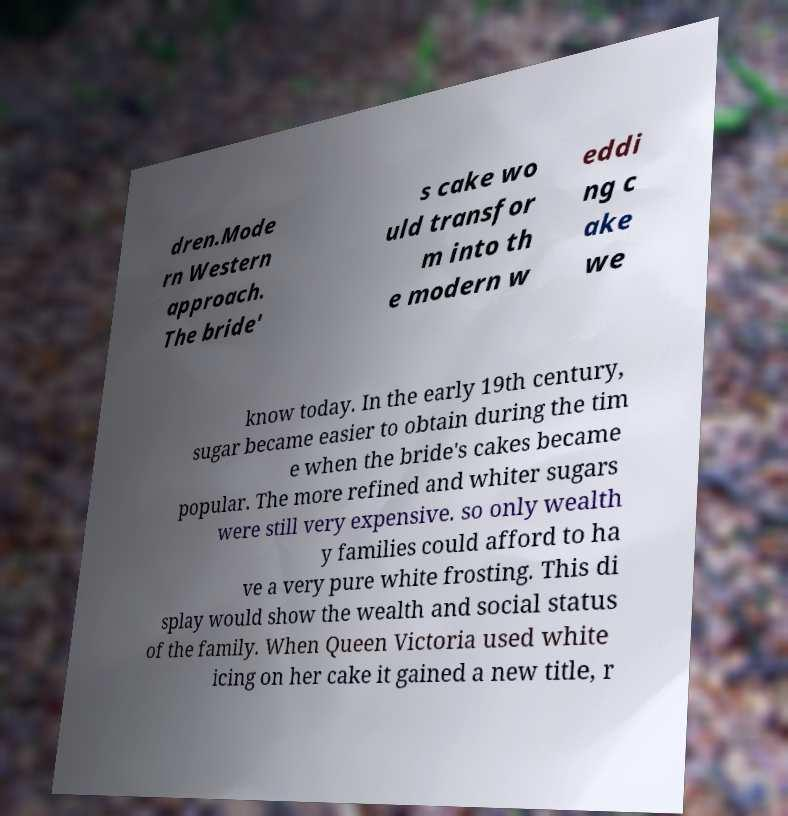There's text embedded in this image that I need extracted. Can you transcribe it verbatim? dren.Mode rn Western approach. The bride' s cake wo uld transfor m into th e modern w eddi ng c ake we know today. In the early 19th century, sugar became easier to obtain during the tim e when the bride's cakes became popular. The more refined and whiter sugars were still very expensive. so only wealth y families could afford to ha ve a very pure white frosting. This di splay would show the wealth and social status of the family. When Queen Victoria used white icing on her cake it gained a new title, r 